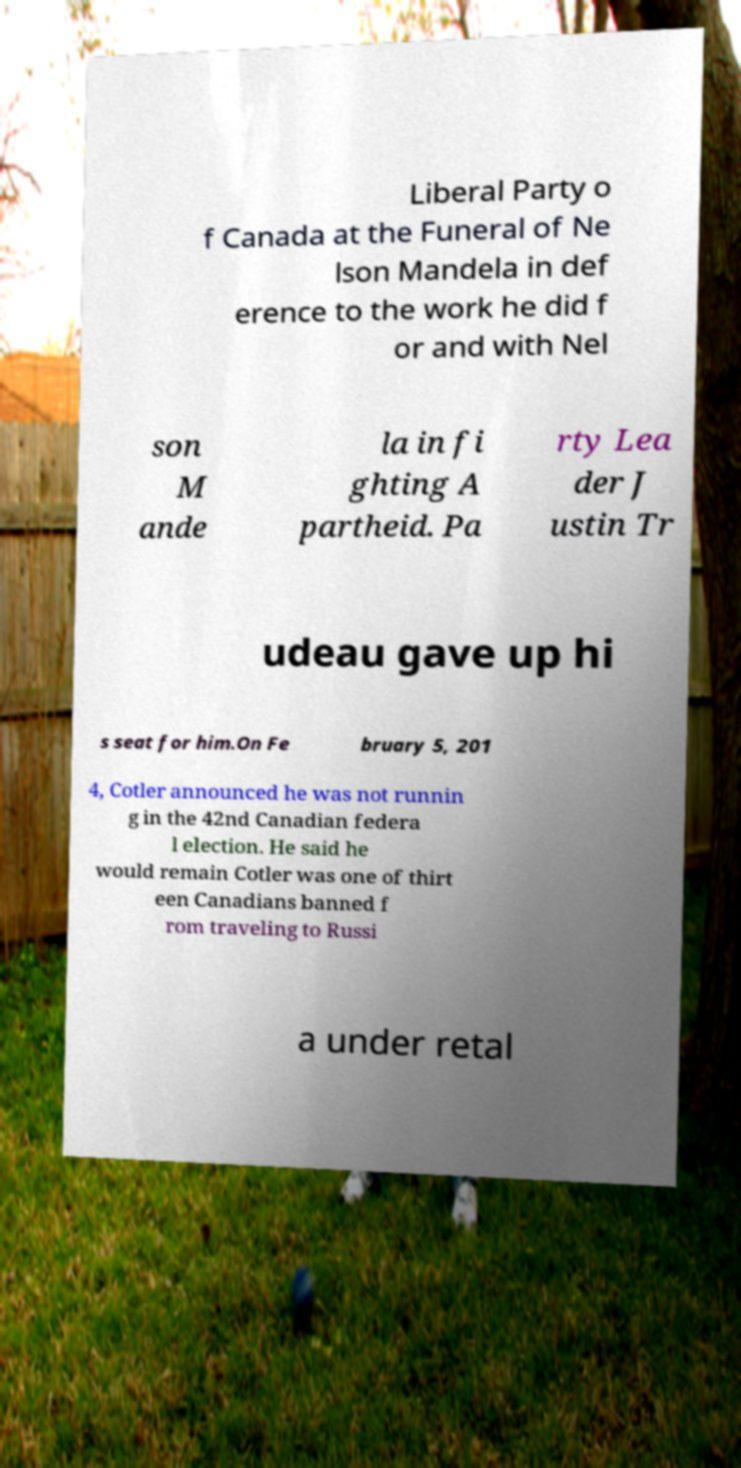Can you read and provide the text displayed in the image?This photo seems to have some interesting text. Can you extract and type it out for me? Liberal Party o f Canada at the Funeral of Ne lson Mandela in def erence to the work he did f or and with Nel son M ande la in fi ghting A partheid. Pa rty Lea der J ustin Tr udeau gave up hi s seat for him.On Fe bruary 5, 201 4, Cotler announced he was not runnin g in the 42nd Canadian federa l election. He said he would remain Cotler was one of thirt een Canadians banned f rom traveling to Russi a under retal 